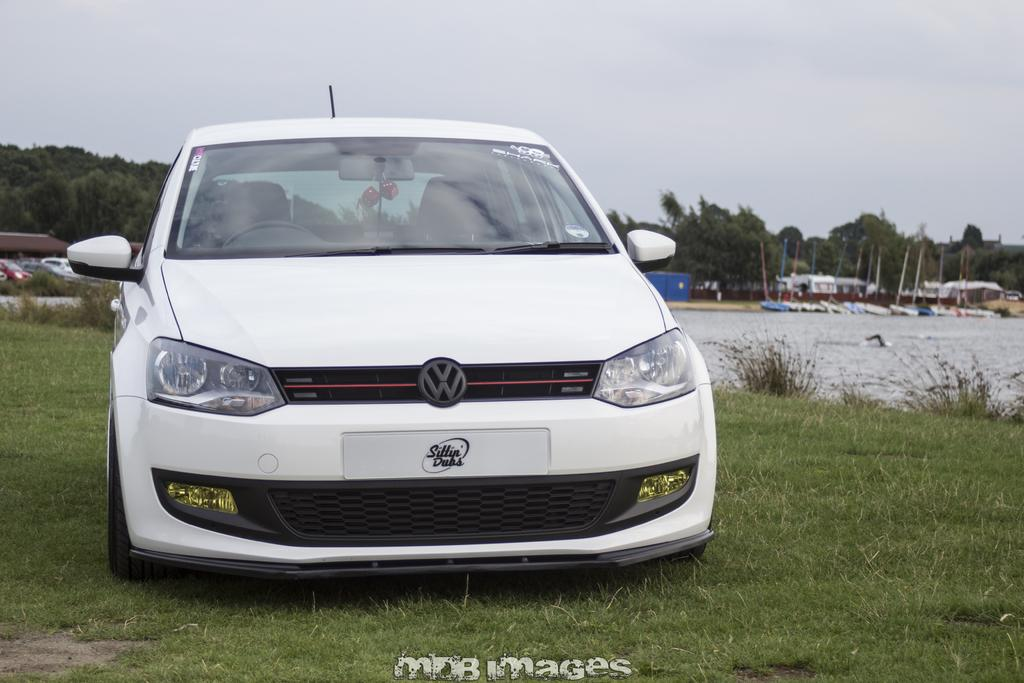What type of vehicle is in the image? There is a white car in the image. What is the ground made of at the bottom of the image? There is green grass at the bottom of the image. What can be seen to the right of the image? There is water visible to the right of the image. What is visible in the background of the image? There are many trees in the background of the image. What is the minister writing on the bat in the image? There is no minister, writing, or bat present in the image. 